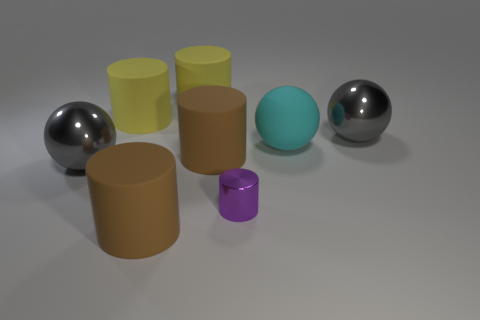What is the shape of the metallic object that is both behind the tiny metallic thing and on the left side of the cyan matte thing?
Provide a short and direct response. Sphere. How many gray metallic spheres are there?
Your answer should be very brief. 2. There is a big gray metal object that is to the right of the big cyan ball; is it the same shape as the small purple metal thing?
Provide a succinct answer. No. There is a large shiny ball that is in front of the cyan sphere; what color is it?
Give a very brief answer. Gray. What number of other things are there of the same size as the purple object?
Your response must be concise. 0. Is there any other thing that has the same shape as the tiny thing?
Offer a very short reply. Yes. Are there the same number of metal things behind the big cyan object and large green shiny blocks?
Offer a terse response. No. What number of other things are made of the same material as the tiny purple thing?
Make the answer very short. 2. Do the large cyan object and the tiny purple thing have the same shape?
Make the answer very short. No. Is there a big brown object that is on the left side of the large yellow matte cylinder on the left side of the big matte thing in front of the tiny cylinder?
Your answer should be compact. No. 